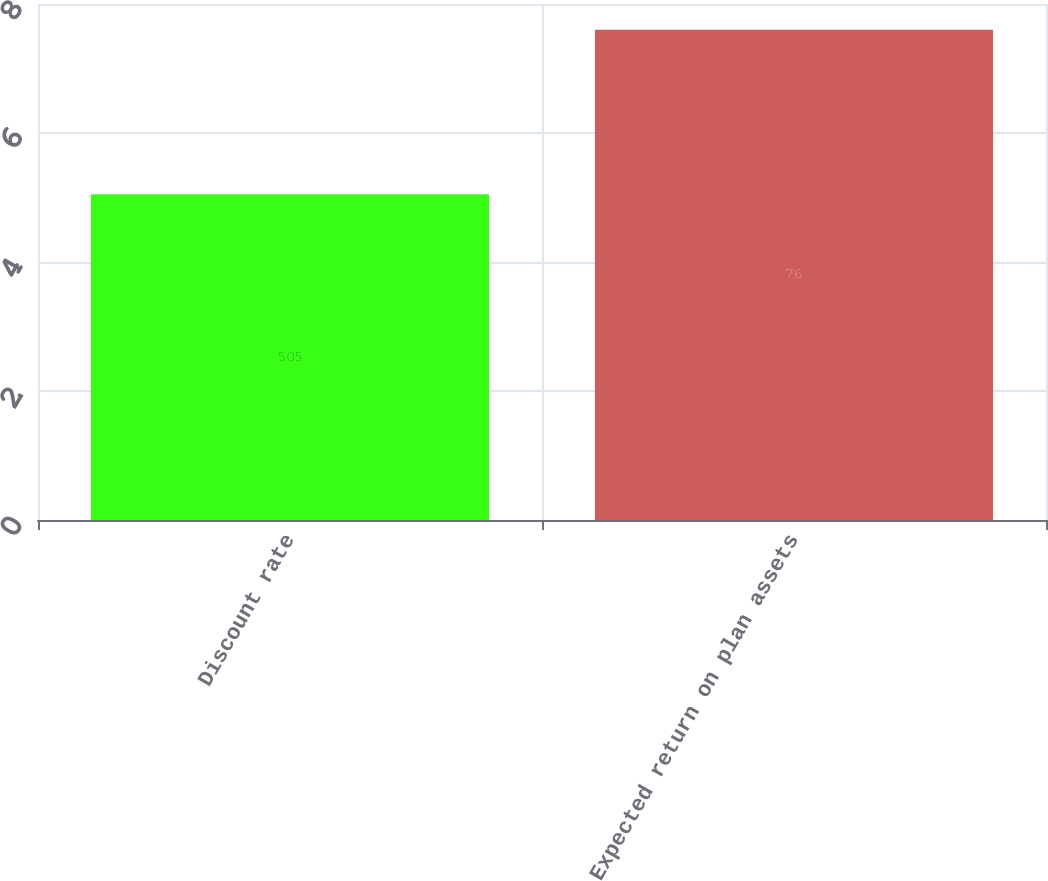<chart> <loc_0><loc_0><loc_500><loc_500><bar_chart><fcel>Discount rate<fcel>Expected return on plan assets<nl><fcel>5.05<fcel>7.6<nl></chart> 